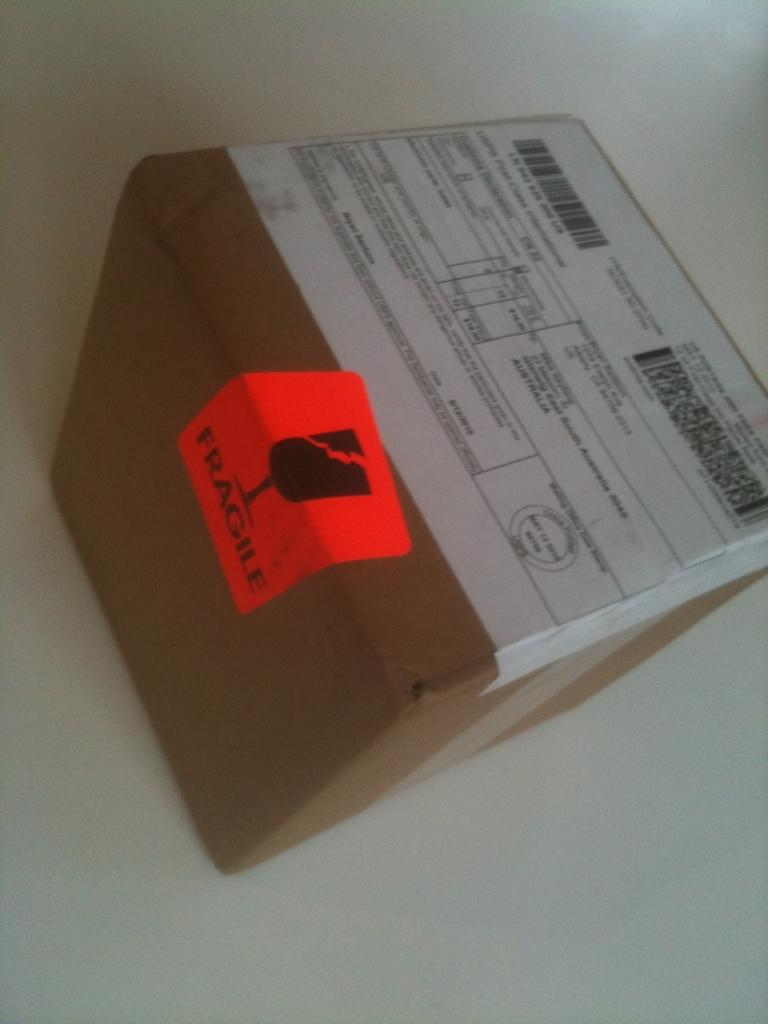<image>
Give a short and clear explanation of the subsequent image. a box reads Fragile and is unopened on a white surface 